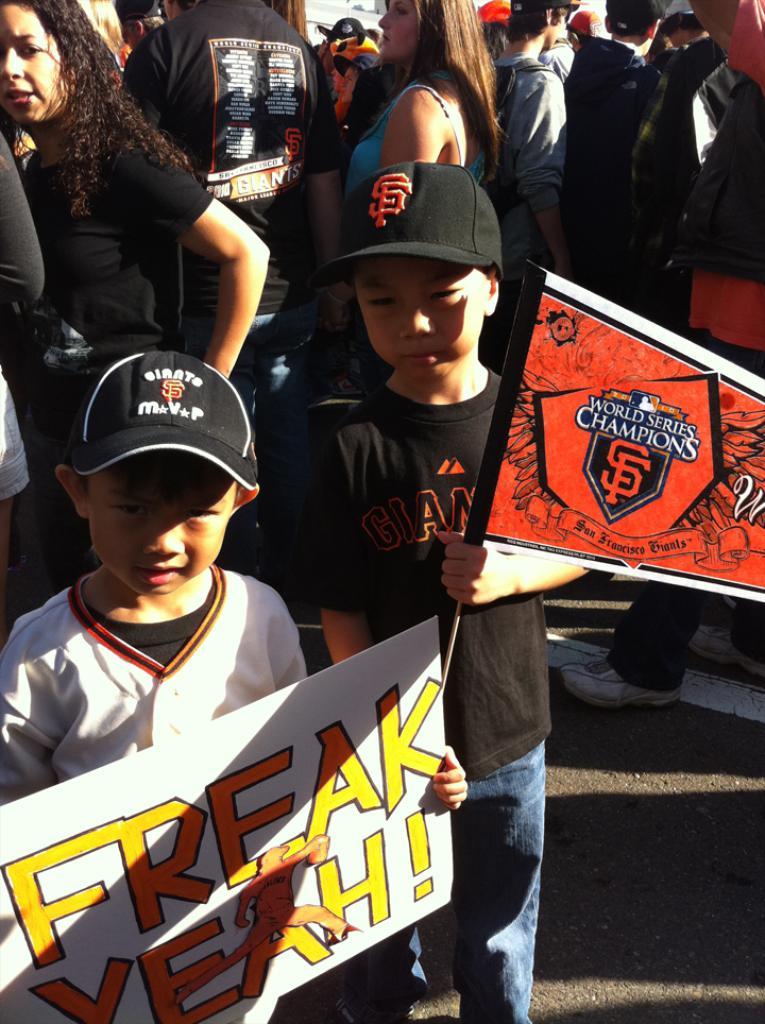What series are they champions of?
Ensure brevity in your answer.  World series. What does the sign on the left say?
Provide a short and direct response. Freak yeah!. 